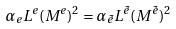<formula> <loc_0><loc_0><loc_500><loc_500>\alpha _ { e } L ^ { e } ( M ^ { e } ) ^ { 2 } = \alpha _ { \tilde { e } } L ^ { \tilde { e } } ( M ^ { \tilde { e } } ) ^ { 2 }</formula> 